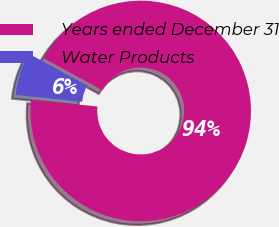Convert chart to OTSL. <chart><loc_0><loc_0><loc_500><loc_500><pie_chart><fcel>Years ended December 31<fcel>Water Products<nl><fcel>93.71%<fcel>6.29%<nl></chart> 